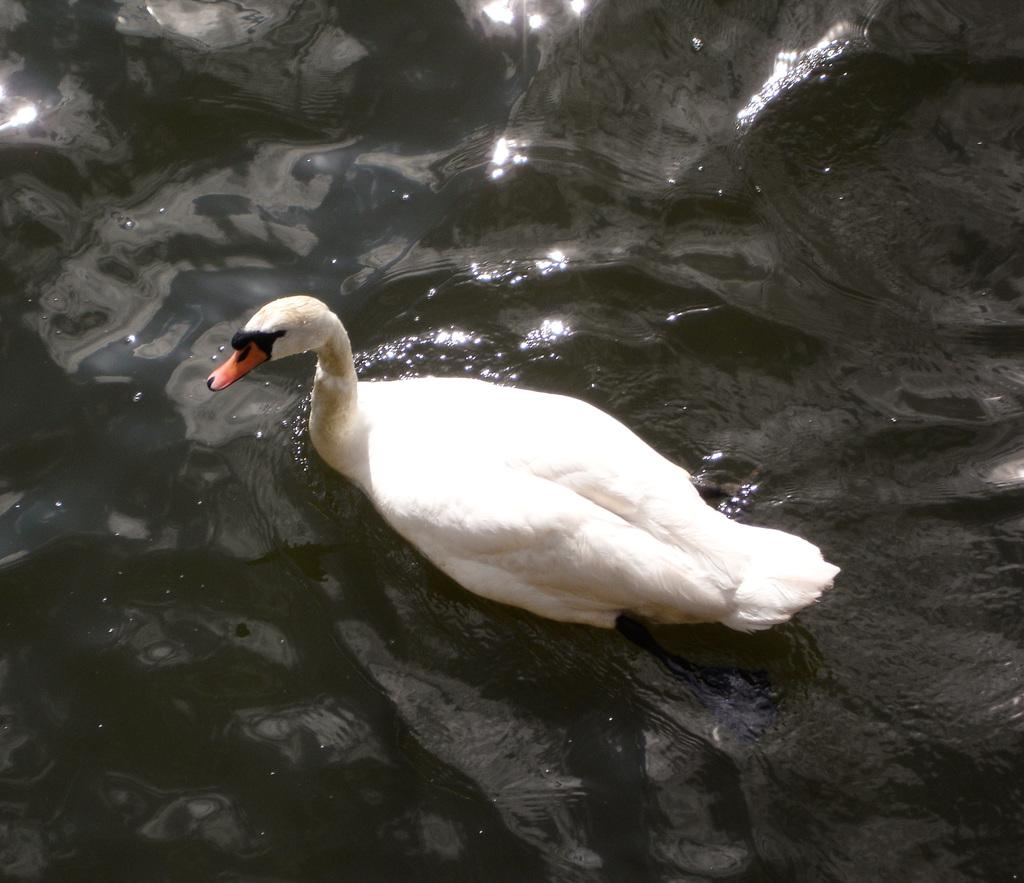What animal is present in the image? There is a duck in the image. Where is the duck located? The duck is on the water. What type of scarecrow can be seen in the image? There is no scarecrow present in the image; it features a duck on the water. How does the wind affect the duck in the image? The image does not show any wind, and therefore its effect on the duck cannot be determined. 